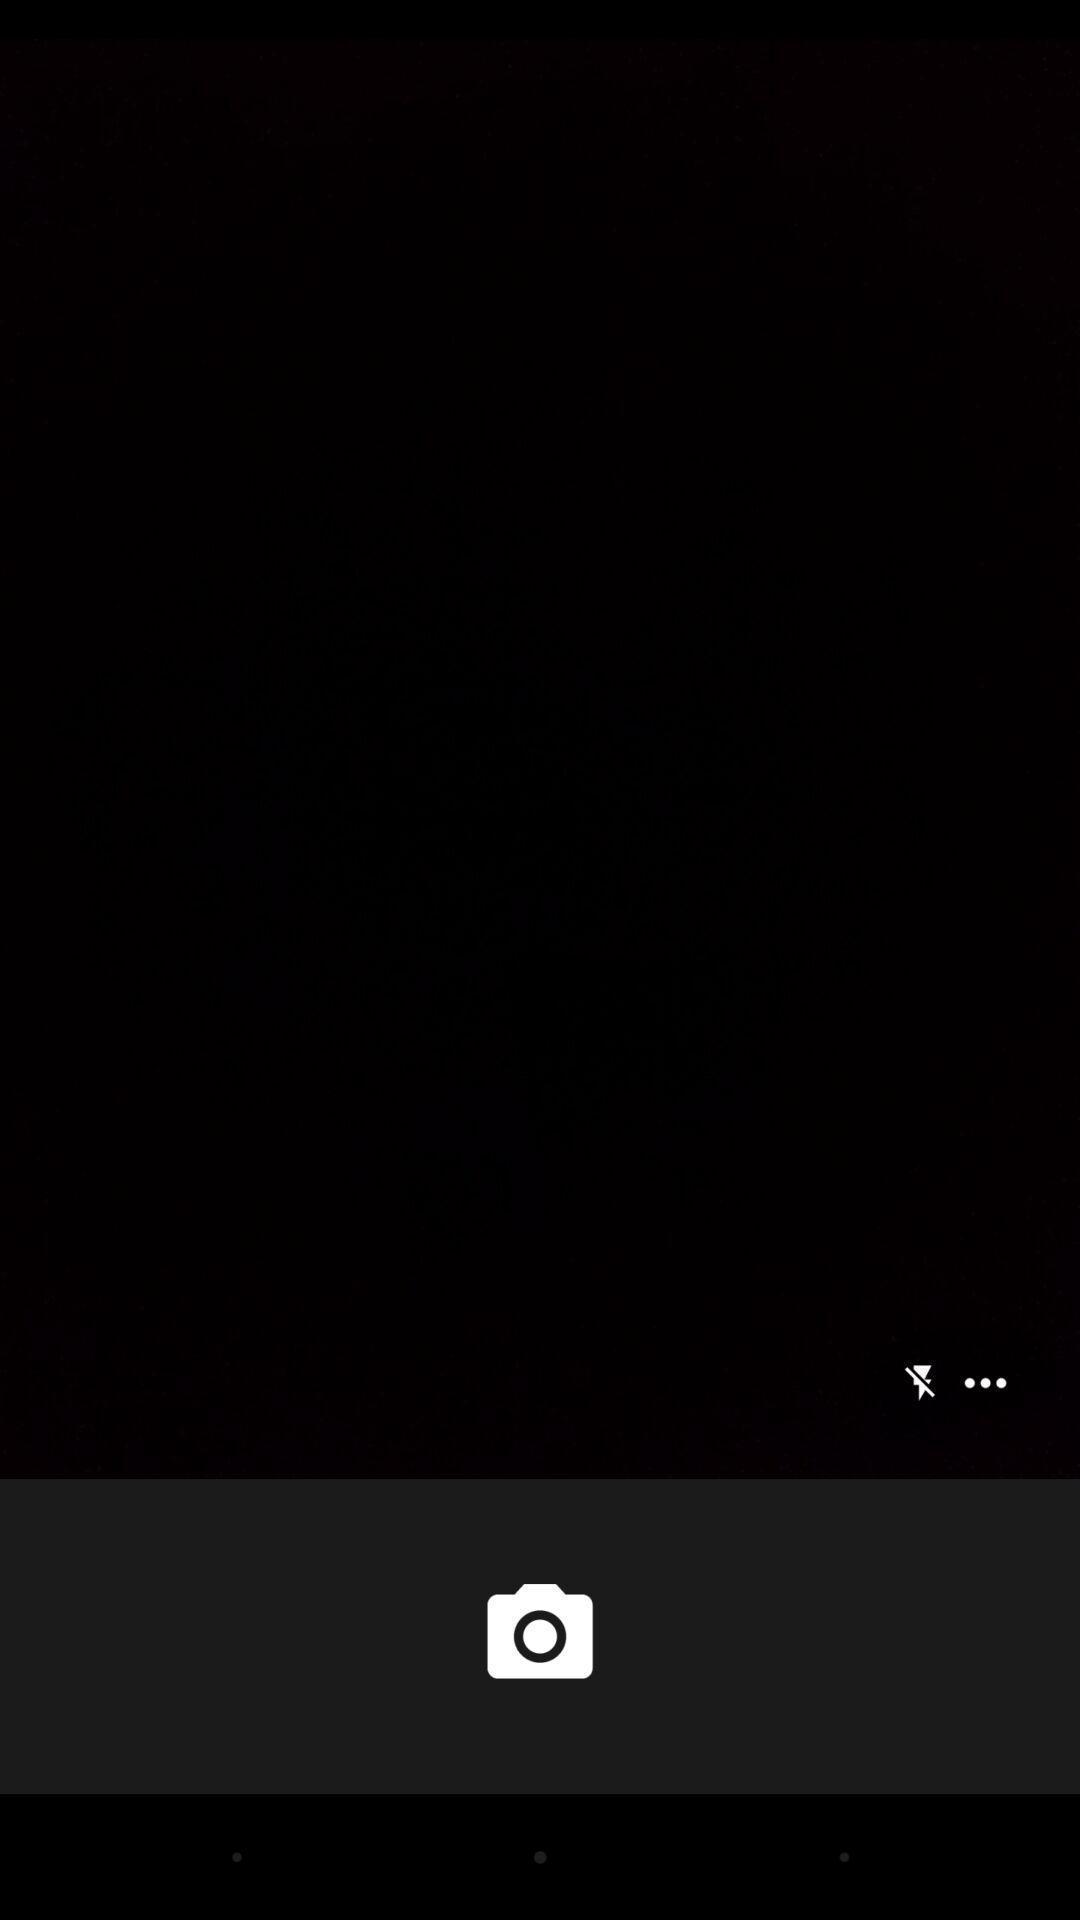Describe this image in words. Page showing camera interface for a baby monitoring app. 